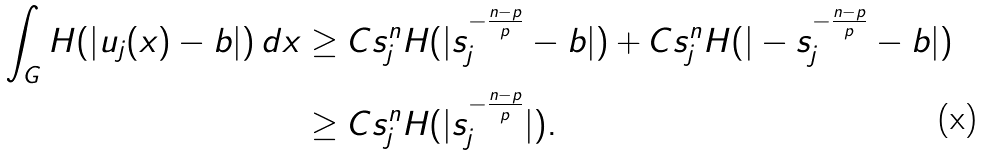<formula> <loc_0><loc_0><loc_500><loc_500>\int _ { G } H ( | u _ { j } ( x ) - b | ) \, d x & \geq C s _ { j } ^ { n } H ( | s _ { j } ^ { - \frac { n - p } { p } } - b | ) + C s _ { j } ^ { n } H ( | - s _ { j } ^ { - \frac { n - p } { p } } - b | ) \\ & \geq C s _ { j } ^ { n } H ( | s _ { j } ^ { - \frac { n - p } { p } } | ) .</formula> 